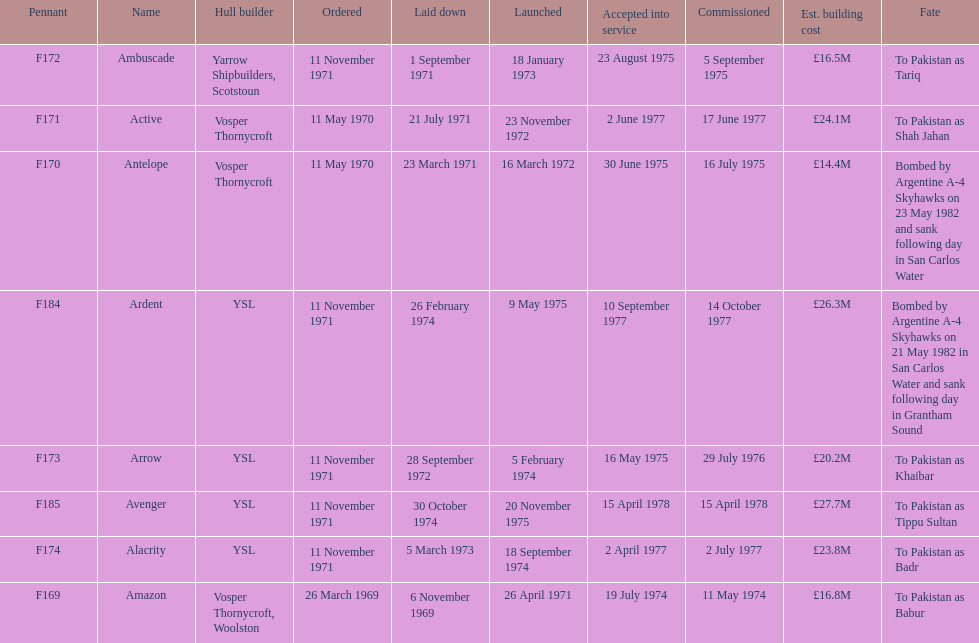How many ships were laid down in september? 2. 